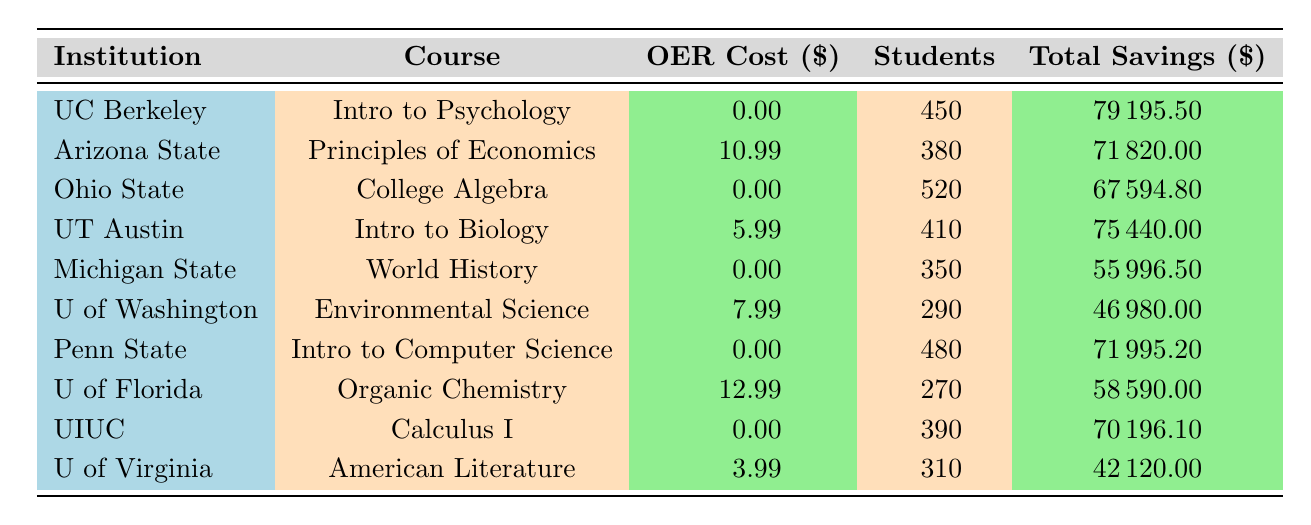What is the OER cost for the "Principles of Economics" course? The OER cost is listed in the table under the course "Principles of Economics" in the row for Arizona State University, which is 10.99.
Answer: 10.99 How many students were enrolled in the "Intro to Psychology" course? The number of students enrolled is specified in the same row as the course title "Intro to Psychology," which indicates 450 students.
Answer: 450 Which course had the highest total savings? To determine the highest total savings, we compare the total savings listed for each course. The maximum value appears for "Intro to Psychology" at 79195.50.
Answer: 79195.50 What is the average OER cost across all courses listed? The OER costs are 0, 10.99, 0, 5.99, 0, 7.99, 0, 12.99, 0, and 3.99, summing them gives 50.95. There are 10 courses, so the average OER cost is 50.95 / 10 = 5.10.
Answer: 5.10 Is the savings from "Environmental Science" greater than 40,000? The total savings for "Environmental Science" is 46980.00, which is greater than 40,000.
Answer: Yes What institution offers the "Organic Chemistry" course, and what are its total savings? The table shows that the University of Florida offers "Organic Chemistry" and the total savings for this course is 58590.00.
Answer: University of Florida, 58590.00 How much more is the traditional textbook cost for "Organic Chemistry" compared to the OER cost? The traditional textbook cost for "Organic Chemistry" is 229.99, while the OER cost is 12.99. The difference is 229.99 - 12.99 = 217.00.
Answer: 217.00 Which course has the lowest number of students enrolled? By comparing the students enrolled for each course, "Organic Chemistry" has the lowest number at 270.
Answer: 270 If the total savings for "World History" was spent equally among all enrolled students, how much would each student save? The total savings for "World History" is 55996.50 with 350 students enrolled. Dividing the total savings by the number of students gives 55996.50 / 350 = 159.14.
Answer: 159.14 